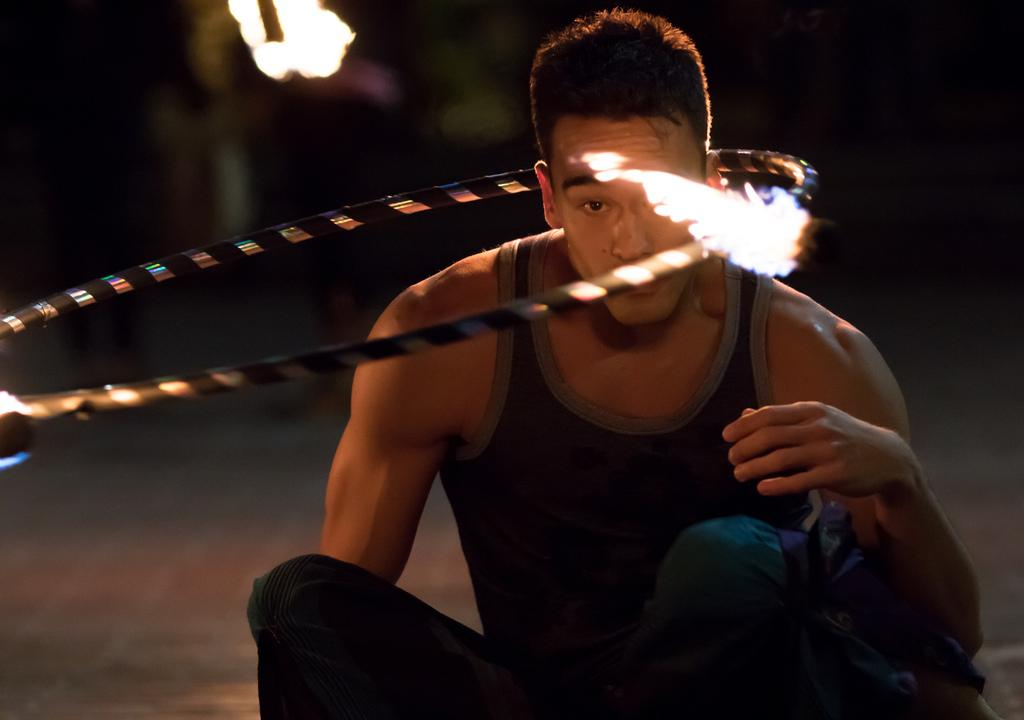What is the man in the image doing? The man is sitting on the ground in the image. What is around the man? There is a rod around the man. What is happening to the rod? There is fire on the rod. Can you describe the background of the image? The background of the image is blurry. What does the man's mom request him to do in the image? There is no mention of the man's mom or any requests in the image. 